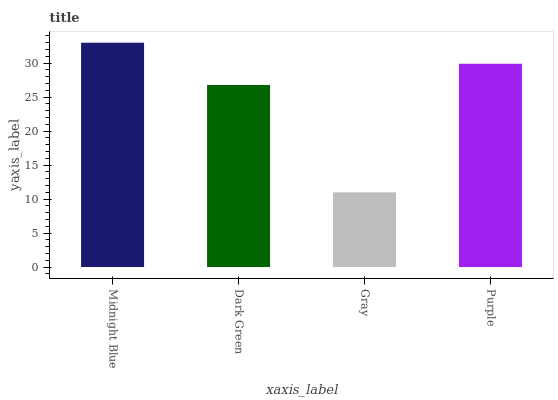Is Gray the minimum?
Answer yes or no. Yes. Is Midnight Blue the maximum?
Answer yes or no. Yes. Is Dark Green the minimum?
Answer yes or no. No. Is Dark Green the maximum?
Answer yes or no. No. Is Midnight Blue greater than Dark Green?
Answer yes or no. Yes. Is Dark Green less than Midnight Blue?
Answer yes or no. Yes. Is Dark Green greater than Midnight Blue?
Answer yes or no. No. Is Midnight Blue less than Dark Green?
Answer yes or no. No. Is Purple the high median?
Answer yes or no. Yes. Is Dark Green the low median?
Answer yes or no. Yes. Is Gray the high median?
Answer yes or no. No. Is Gray the low median?
Answer yes or no. No. 